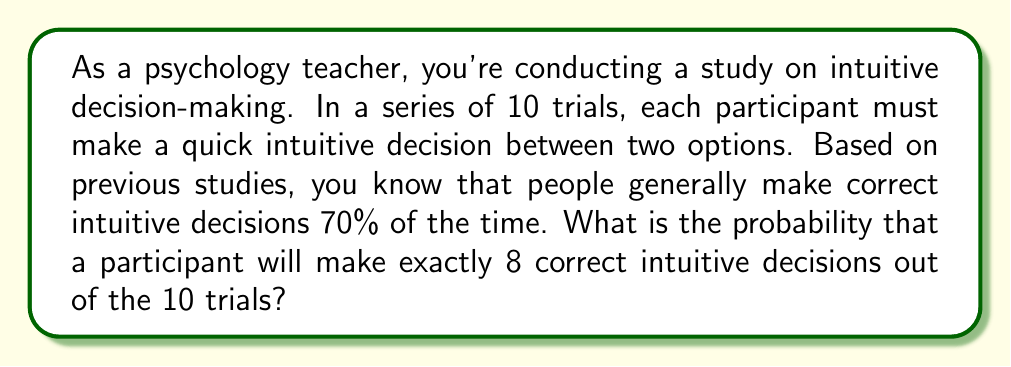Help me with this question. To solve this problem, we need to use the binomial probability formula. This is appropriate because:
1. We have a fixed number of trials (10)
2. Each trial has two possible outcomes (correct or incorrect)
3. The probability of success (correct decision) remains constant for each trial
4. The trials are independent

The binomial probability formula is:

$$P(X = k) = \binom{n}{k} p^k (1-p)^{n-k}$$

Where:
- $n$ is the number of trials (10)
- $k$ is the number of successes (8)
- $p$ is the probability of success on each trial (0.70)

Let's solve step by step:

1. Calculate $\binom{n}{k}$:
   $$\binom{10}{8} = \frac{10!}{8!(10-8)!} = \frac{10!}{8!2!} = 45$$

2. Calculate $p^k$:
   $$0.70^8 \approx 0.0576$$

3. Calculate $(1-p)^{n-k}$:
   $$(1-0.70)^{10-8} = 0.30^2 = 0.09$$

4. Multiply all parts together:
   $$45 \times 0.0576 \times 0.09 \approx 0.2333$$

Therefore, the probability of making exactly 8 correct intuitive decisions out of 10 trials is approximately 0.2333 or 23.33%.
Answer: 0.2333 or 23.33% 